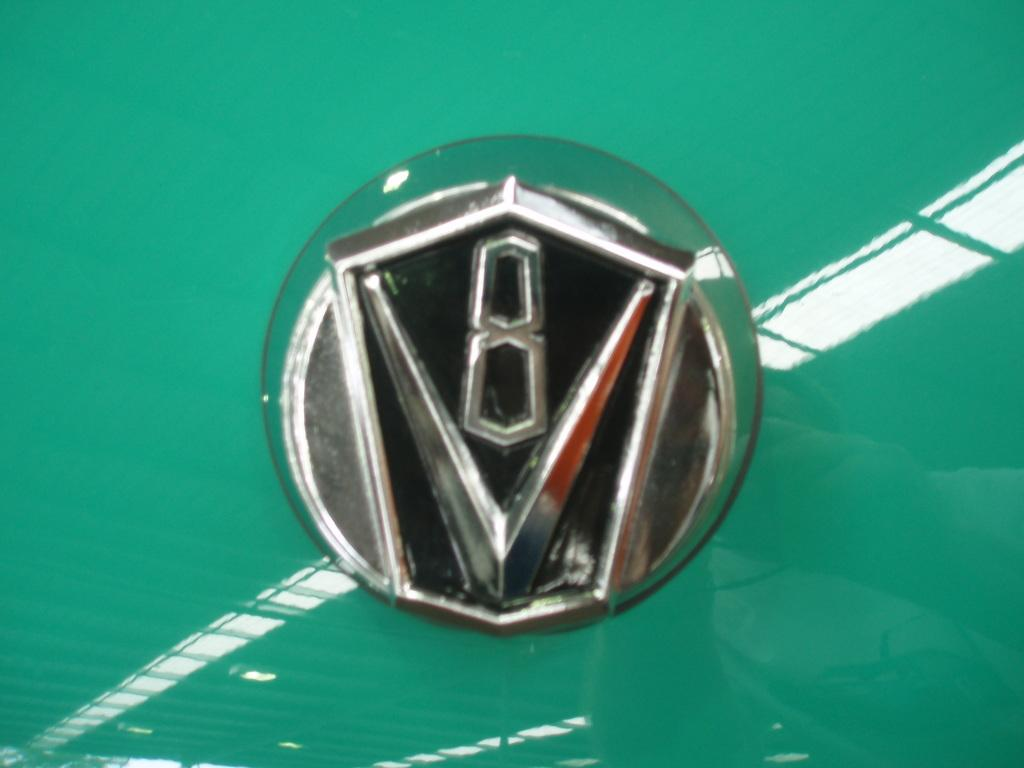What is the main subject of the image? The main subject of the image is a car logo. Can you describe the car logo in the image? The car logo is located in the center of the image. What historical event is depicted in the car logo? The car logo does not depict any historical event; it is simply a logo for a car brand. How many chickens are present in the car logo? There are no chickens present in the car logo; it is a car logo, not a depiction of animals. 